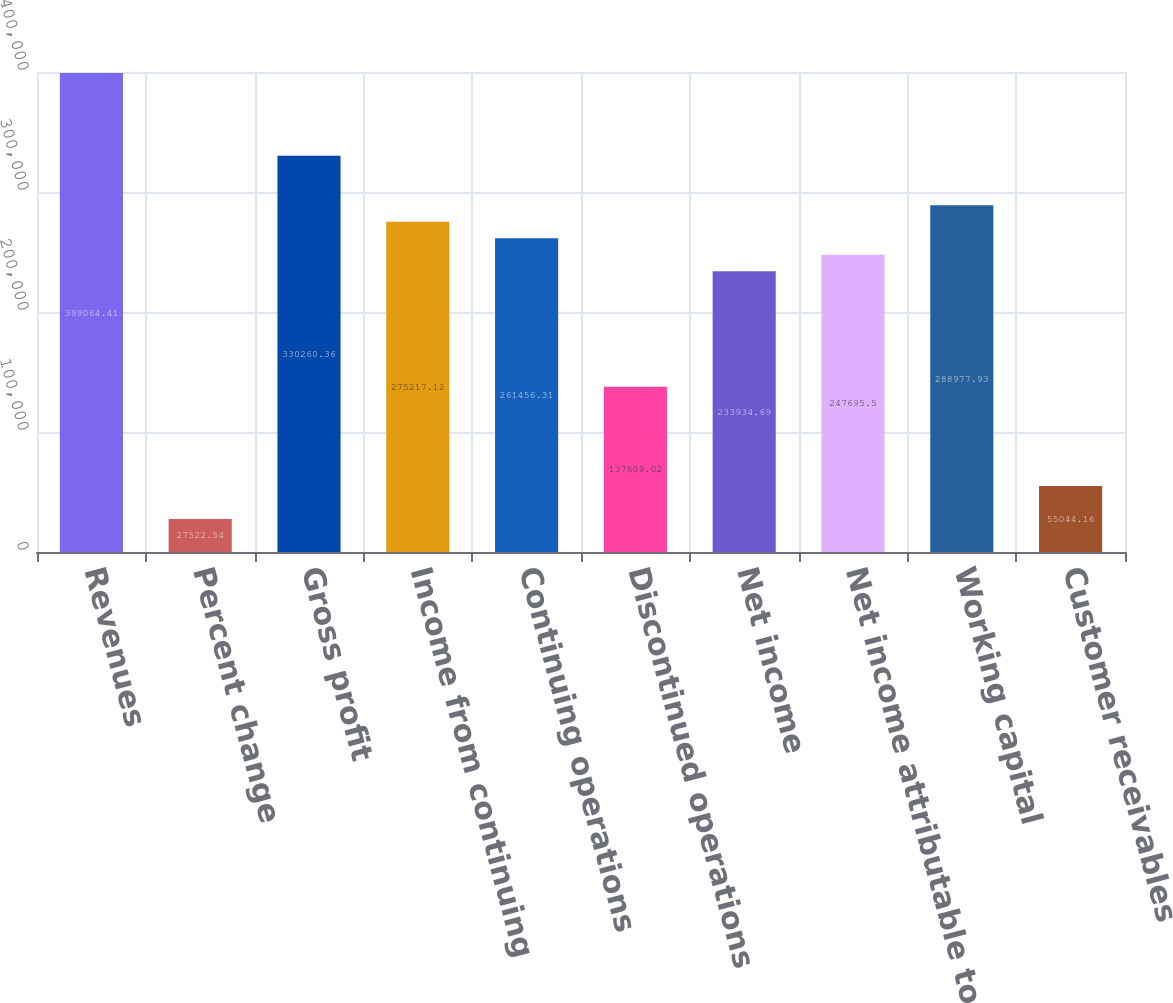<chart> <loc_0><loc_0><loc_500><loc_500><bar_chart><fcel>Revenues<fcel>Percent change<fcel>Gross profit<fcel>Income from continuing<fcel>Continuing operations<fcel>Discontinued operations<fcel>Net income<fcel>Net income attributable to<fcel>Working capital<fcel>Customer receivables<nl><fcel>399064<fcel>27522.5<fcel>330260<fcel>275217<fcel>261456<fcel>137609<fcel>233935<fcel>247696<fcel>288978<fcel>55044.2<nl></chart> 